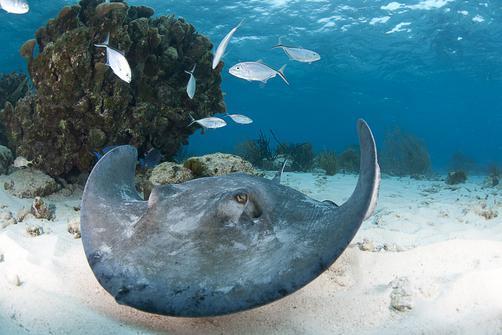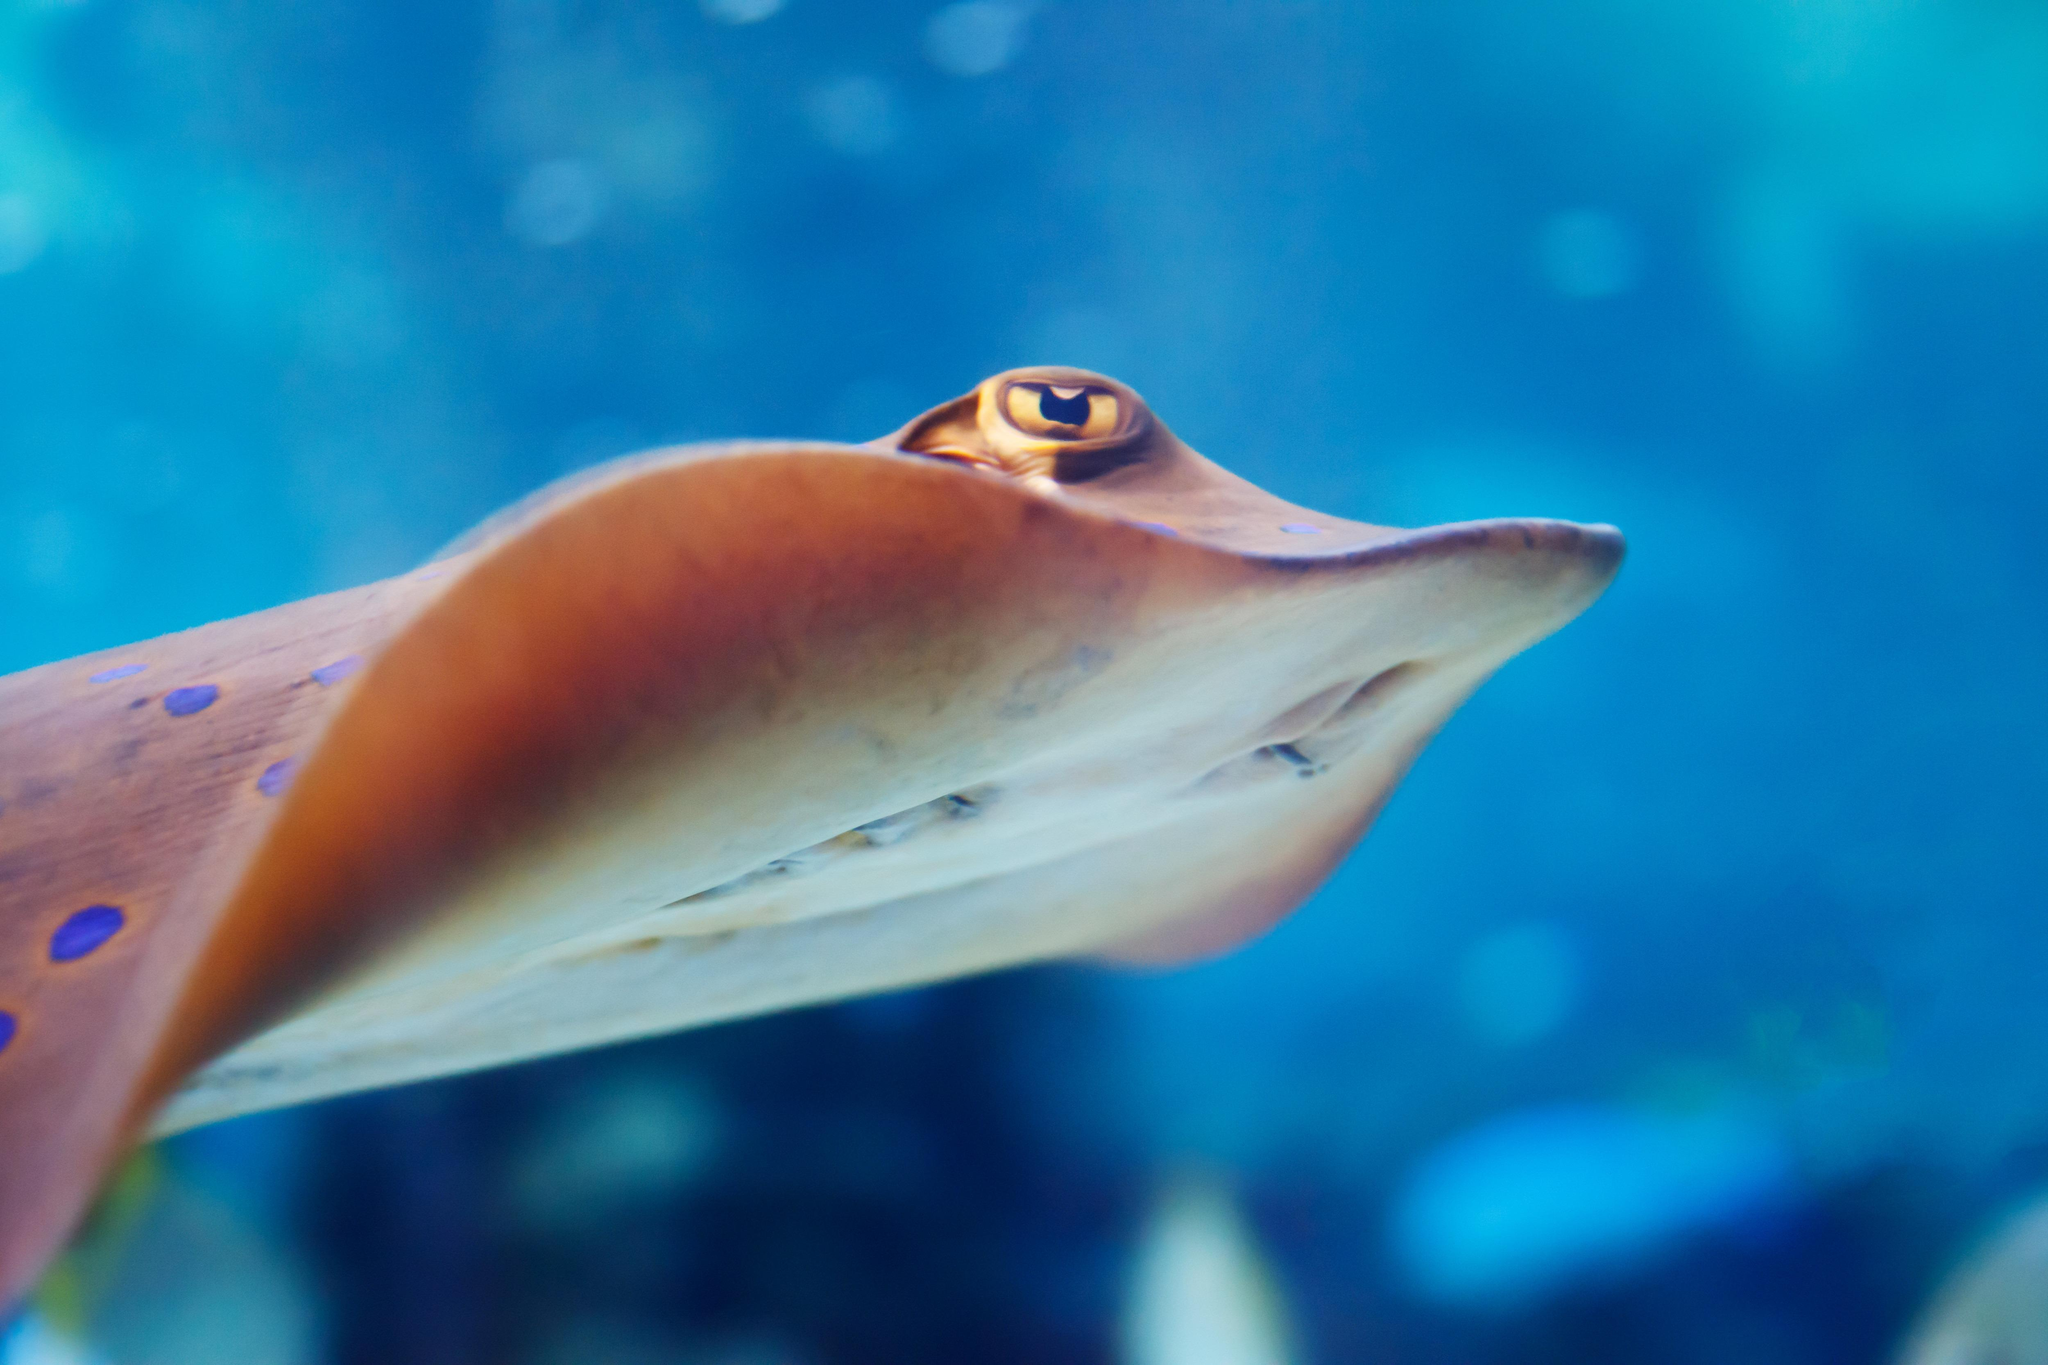The first image is the image on the left, the second image is the image on the right. Assess this claim about the two images: "The left and right image contains the same number stingrays with at least one with blue dots.". Correct or not? Answer yes or no. Yes. The first image is the image on the left, the second image is the image on the right. For the images displayed, is the sentence "The ocean floor is visible in both images." factually correct? Answer yes or no. No. 